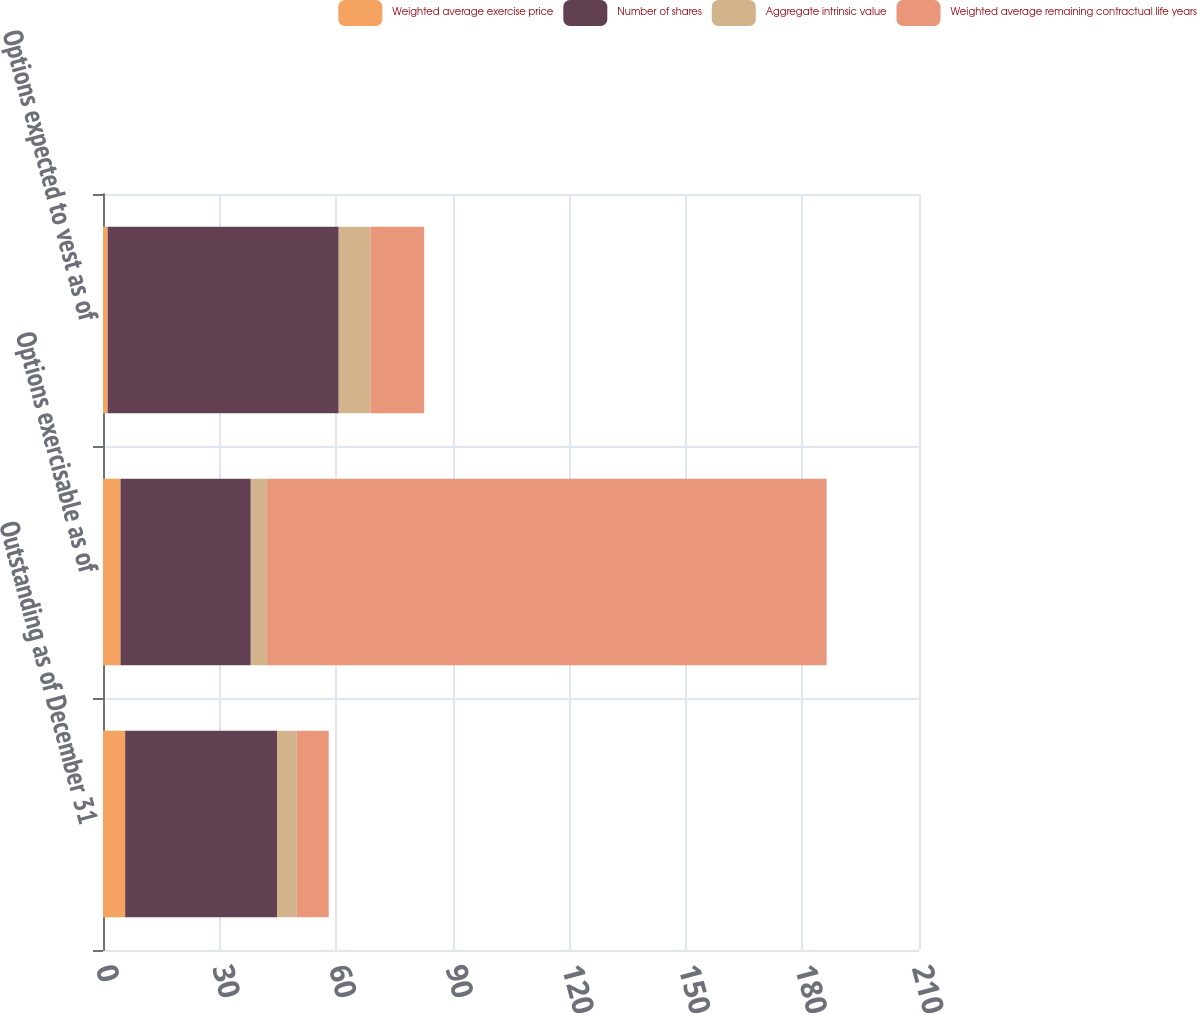Convert chart. <chart><loc_0><loc_0><loc_500><loc_500><stacked_bar_chart><ecel><fcel>Outstanding as of December 31<fcel>Options exercisable as of<fcel>Options expected to vest as of<nl><fcel>Weighted average exercise price<fcel>5.7<fcel>4.5<fcel>1.2<nl><fcel>Number of shares<fcel>39.08<fcel>33.53<fcel>59.46<nl><fcel>Aggregate intrinsic value<fcel>5.1<fcel>4.2<fcel>8.2<nl><fcel>Weighted average remaining contractual life years<fcel>8.2<fcel>144<fcel>13.8<nl></chart> 